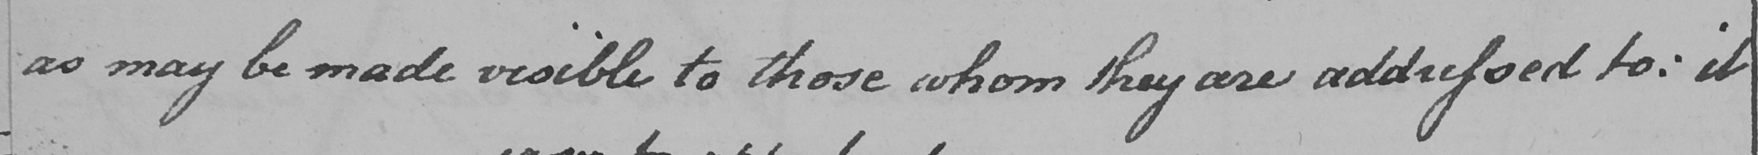Transcribe the text shown in this historical manuscript line. as may be made visible to those whom they are addressed to :  it 